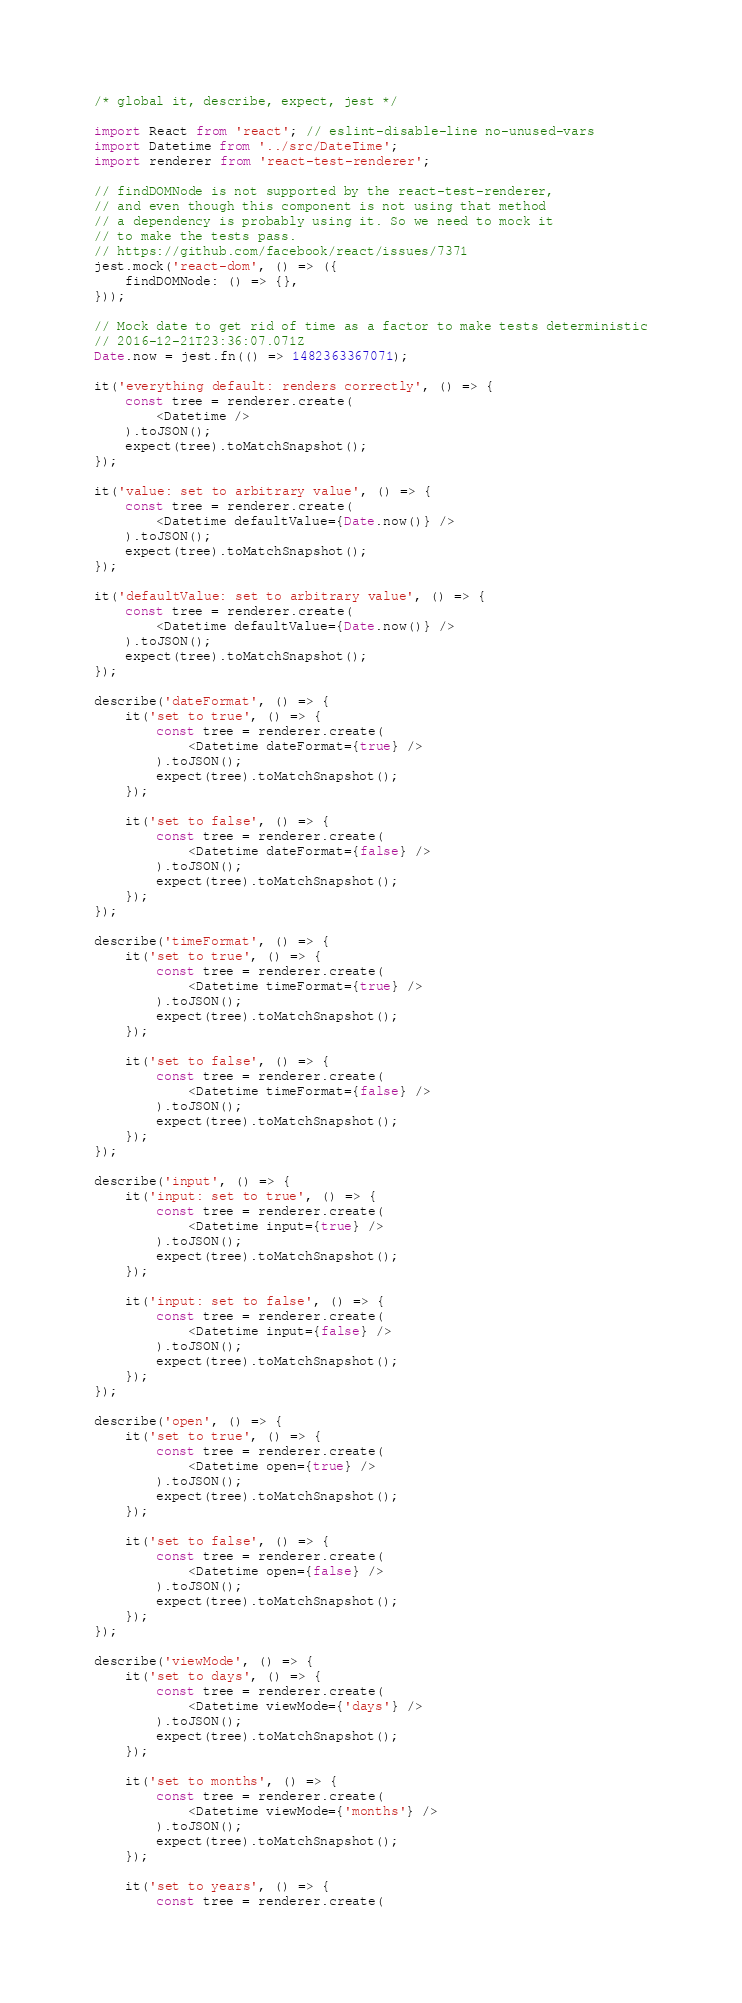<code> <loc_0><loc_0><loc_500><loc_500><_JavaScript_>/* global it, describe, expect, jest */

import React from 'react'; // eslint-disable-line no-unused-vars
import Datetime from '../src/DateTime';
import renderer from 'react-test-renderer';

// findDOMNode is not supported by the react-test-renderer,
// and even though this component is not using that method
// a dependency is probably using it. So we need to mock it
// to make the tests pass.
// https://github.com/facebook/react/issues/7371
jest.mock('react-dom', () => ({
	findDOMNode: () => {},
}));

// Mock date to get rid of time as a factor to make tests deterministic
// 2016-12-21T23:36:07.071Z
Date.now = jest.fn(() => 1482363367071);

it('everything default: renders correctly', () => {
	const tree = renderer.create(
		<Datetime />
	).toJSON();
	expect(tree).toMatchSnapshot();
});

it('value: set to arbitrary value', () => {
	const tree = renderer.create(
		<Datetime defaultValue={Date.now()} />
	).toJSON();
	expect(tree).toMatchSnapshot();
});

it('defaultValue: set to arbitrary value', () => {
	const tree = renderer.create(
		<Datetime defaultValue={Date.now()} />
	).toJSON();
	expect(tree).toMatchSnapshot();
});

describe('dateFormat', () => {
	it('set to true', () => {
		const tree = renderer.create(
			<Datetime dateFormat={true} />
		).toJSON();
		expect(tree).toMatchSnapshot();
	});

	it('set to false', () => {
		const tree = renderer.create(
			<Datetime dateFormat={false} />
		).toJSON();
		expect(tree).toMatchSnapshot();
	});
});

describe('timeFormat', () => {
	it('set to true', () => {
		const tree = renderer.create(
			<Datetime timeFormat={true} />
		).toJSON();
		expect(tree).toMatchSnapshot();
	});

	it('set to false', () => {
		const tree = renderer.create(
			<Datetime timeFormat={false} />
		).toJSON();
		expect(tree).toMatchSnapshot();
	});
});

describe('input', () => {
	it('input: set to true', () => {
		const tree = renderer.create(
			<Datetime input={true} />
		).toJSON();
		expect(tree).toMatchSnapshot();
	});

	it('input: set to false', () => {
		const tree = renderer.create(
			<Datetime input={false} />
		).toJSON();
		expect(tree).toMatchSnapshot();
	});
});

describe('open', () => {
	it('set to true', () => {
		const tree = renderer.create(
			<Datetime open={true} />
		).toJSON();
		expect(tree).toMatchSnapshot();
	});

	it('set to false', () => {
		const tree = renderer.create(
			<Datetime open={false} />
		).toJSON();
		expect(tree).toMatchSnapshot();
	});
});

describe('viewMode', () => {
	it('set to days', () => {
		const tree = renderer.create(
			<Datetime viewMode={'days'} />
		).toJSON();
		expect(tree).toMatchSnapshot();
	});

	it('set to months', () => {
		const tree = renderer.create(
			<Datetime viewMode={'months'} />
		).toJSON();
		expect(tree).toMatchSnapshot();
	});

	it('set to years', () => {
		const tree = renderer.create(</code> 